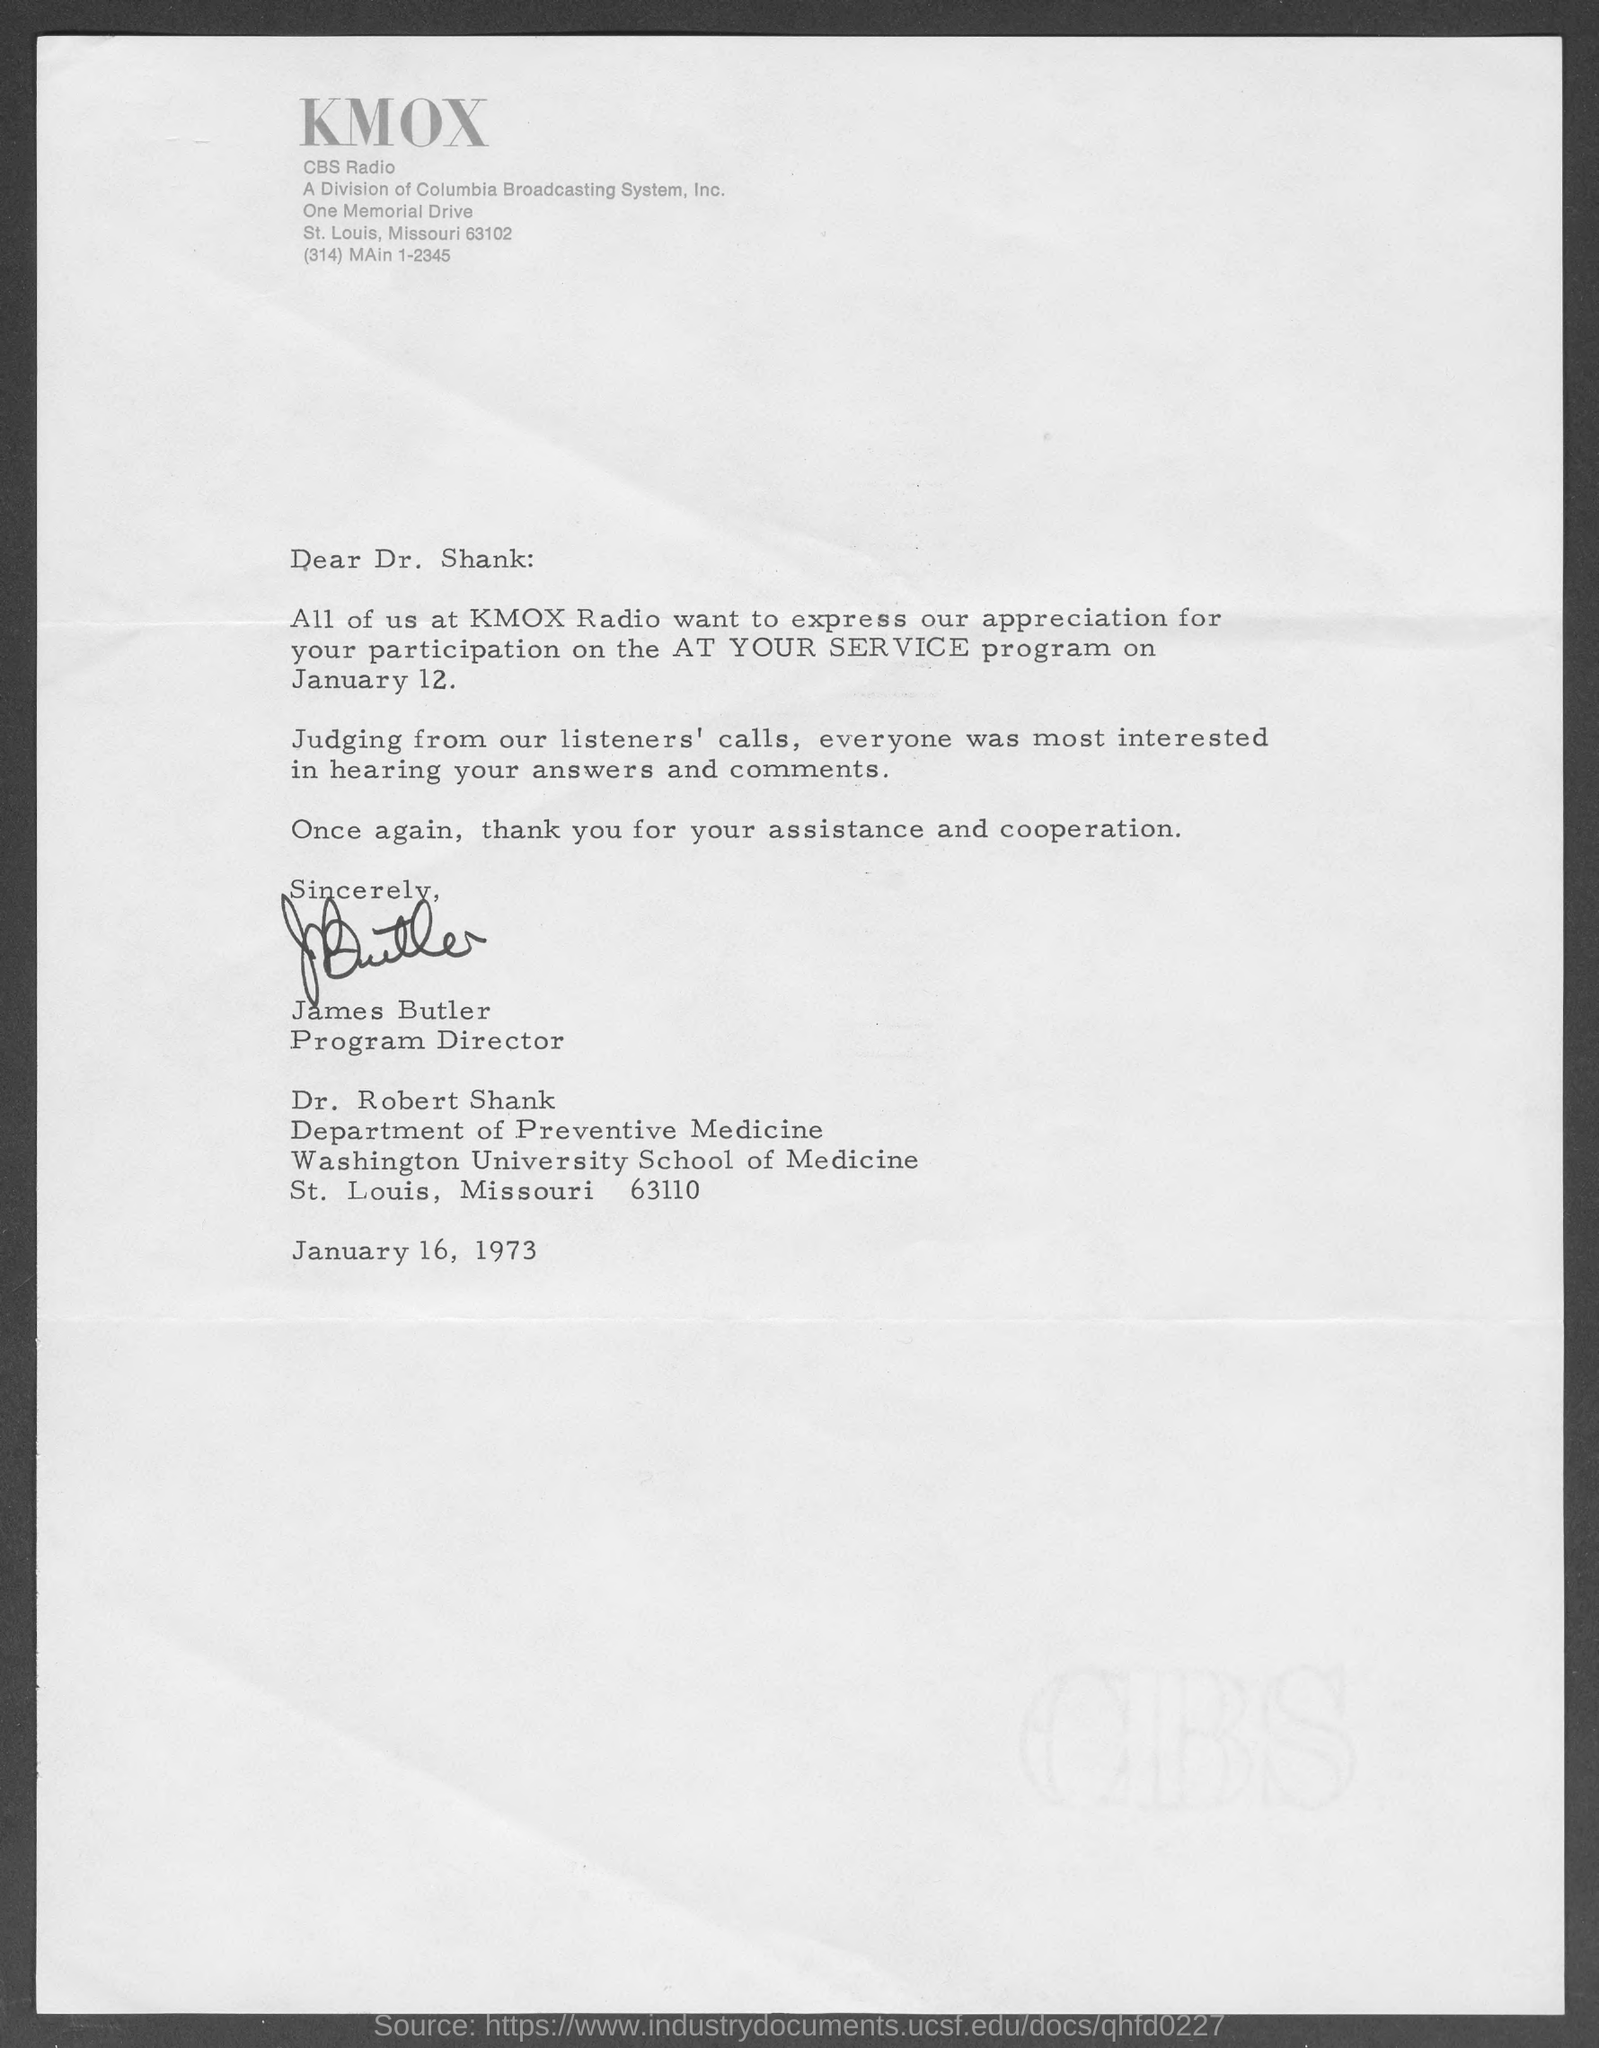Give some essential details in this illustration. James Butler is the program director at KMOX Radio. The program name is At Your Service. 